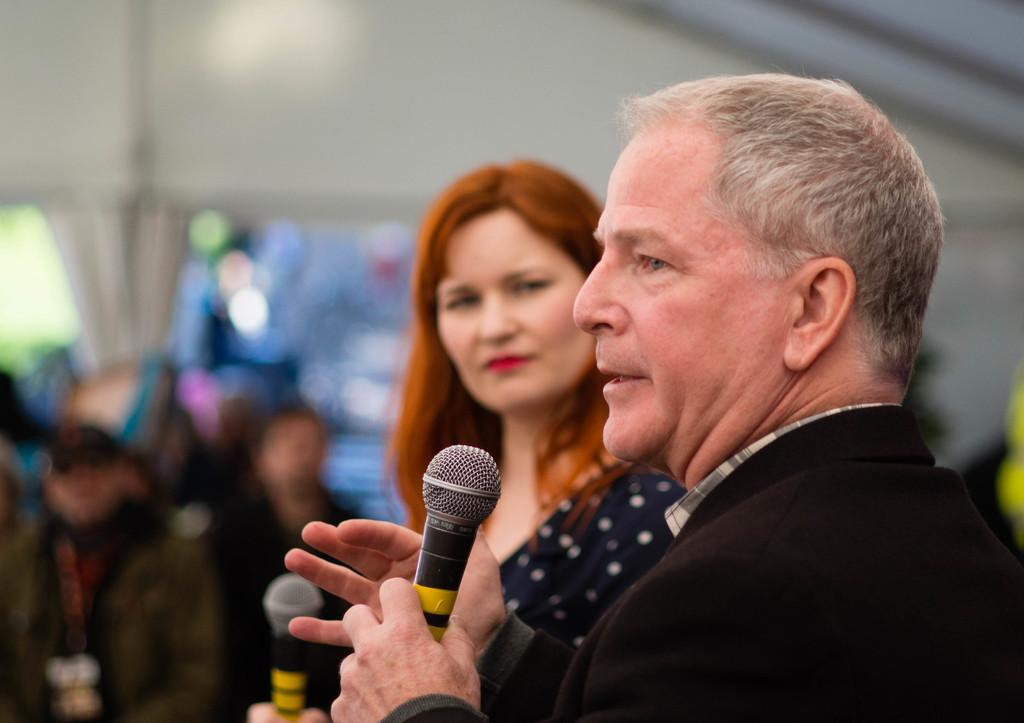Who is the main subject in the image? There is a man in the image. What is the man doing in the image? The man is holding a microphone and speaking. Who else is present in the image? There is a woman in the image. What is the woman doing in the image? The woman is watching the man. What type of print can be seen on the alley wall in the image? There is no alley or print visible in the image; it features a man holding a microphone and speaking, with a woman watching him. 